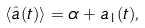<formula> <loc_0><loc_0><loc_500><loc_500>\langle \hat { a } ( t ) \rangle = \alpha + a _ { 1 } ( t ) ,</formula> 